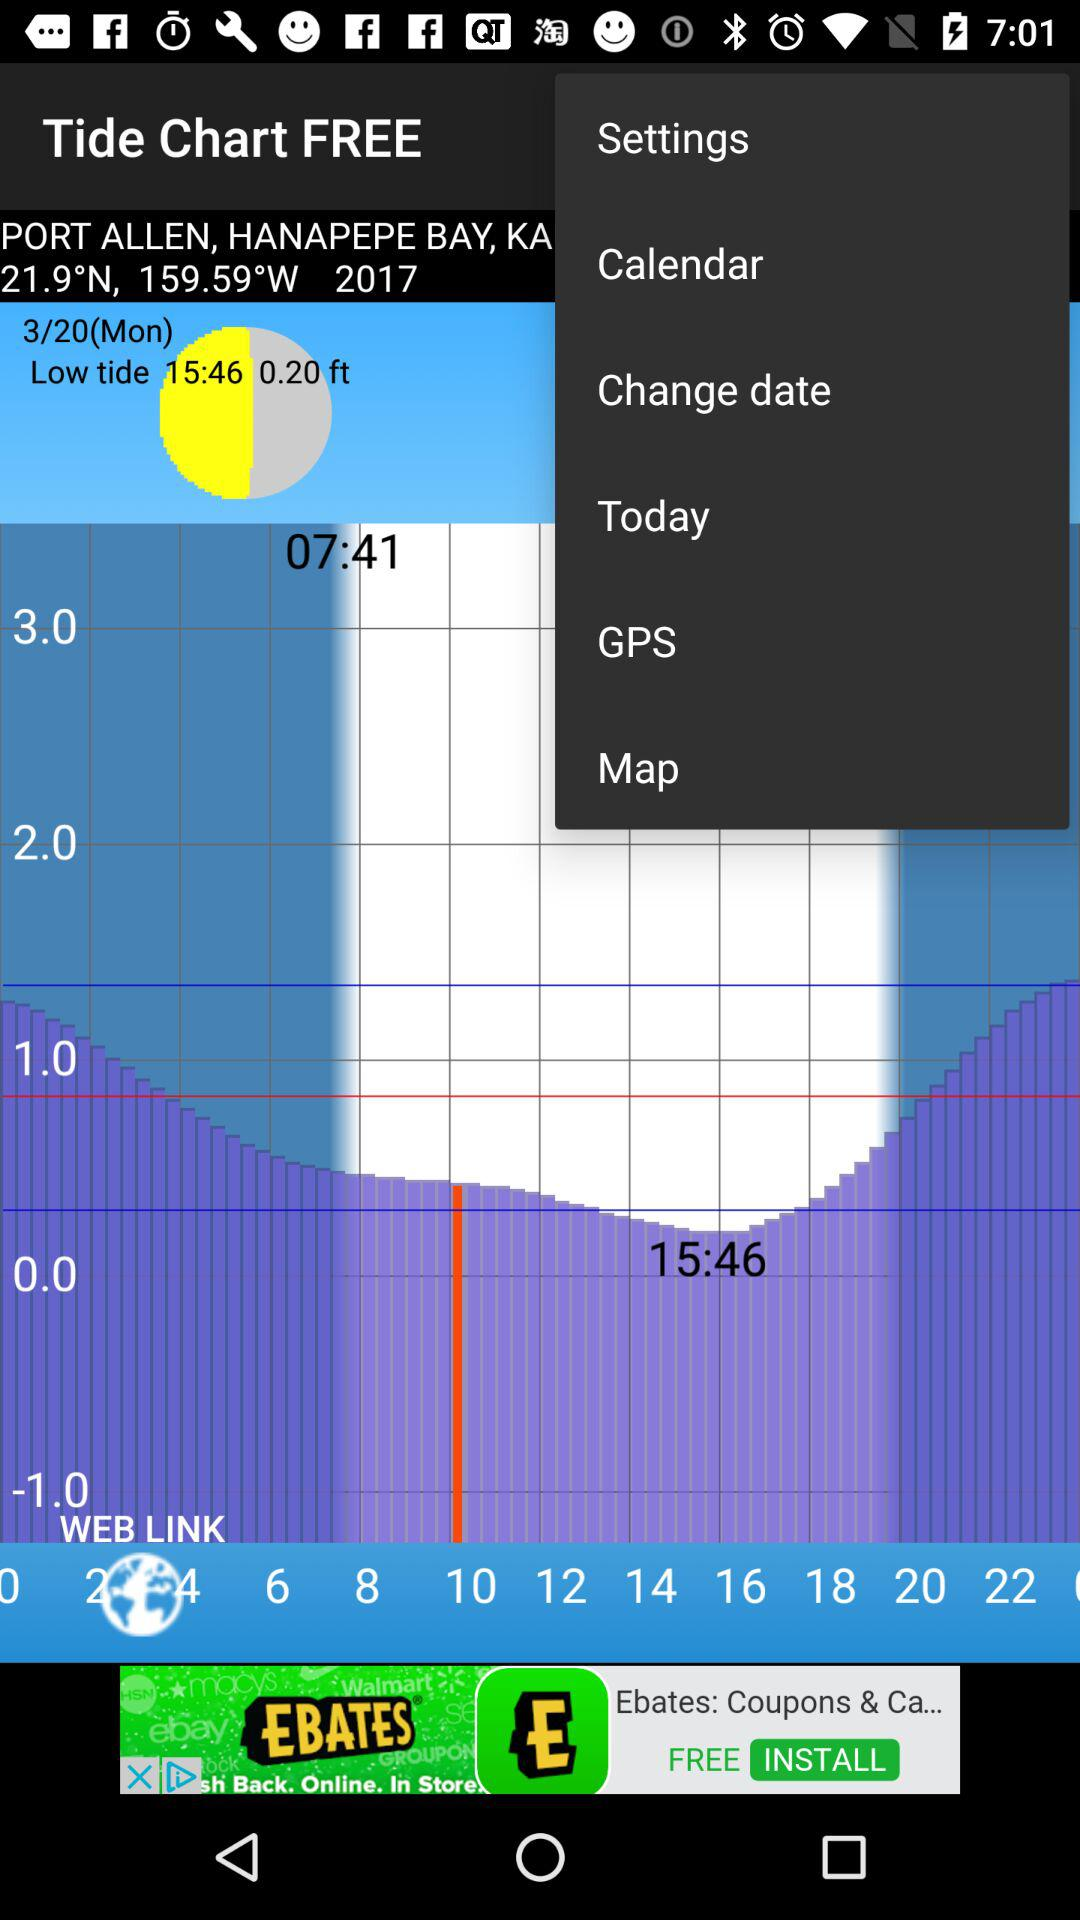What location is selected? The location is Port Allen, Hanapepe Bay. 